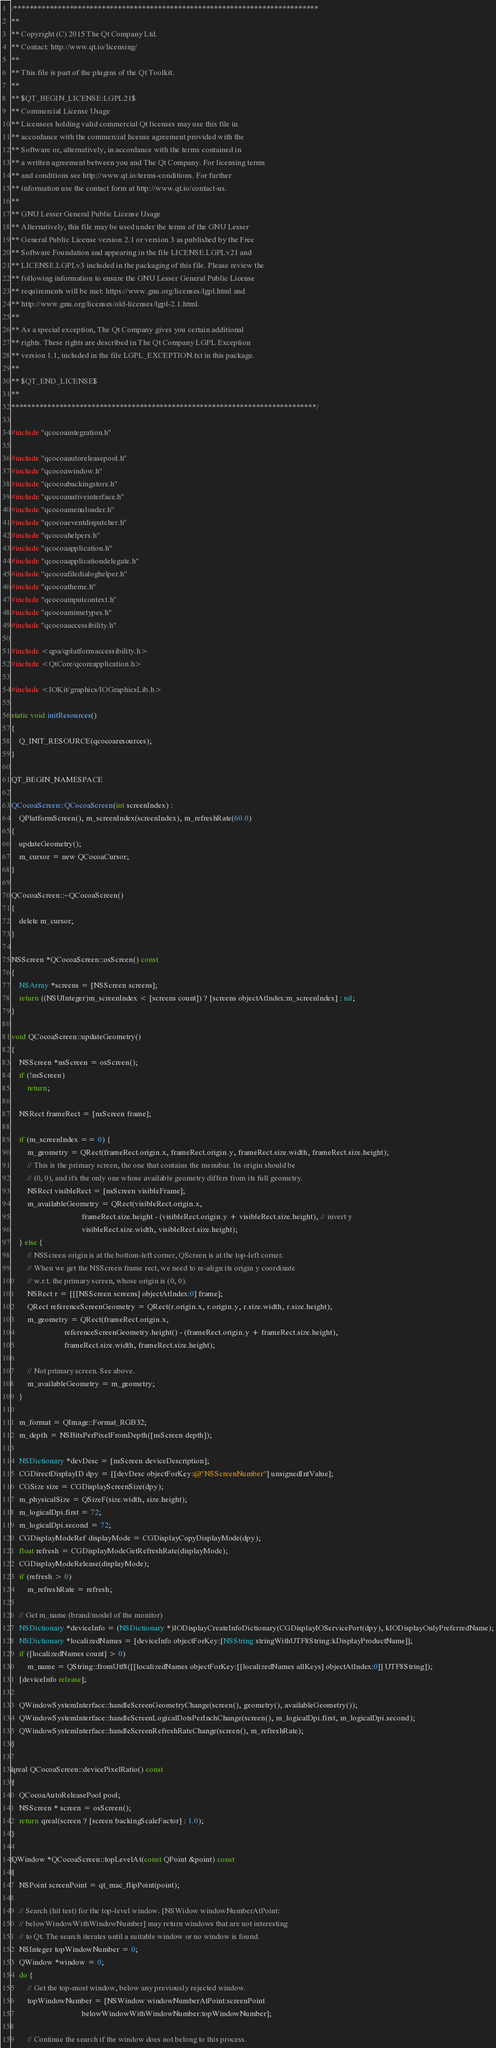<code> <loc_0><loc_0><loc_500><loc_500><_ObjectiveC_>/****************************************************************************
**
** Copyright (C) 2015 The Qt Company Ltd.
** Contact: http://www.qt.io/licensing/
**
** This file is part of the plugins of the Qt Toolkit.
**
** $QT_BEGIN_LICENSE:LGPL21$
** Commercial License Usage
** Licensees holding valid commercial Qt licenses may use this file in
** accordance with the commercial license agreement provided with the
** Software or, alternatively, in accordance with the terms contained in
** a written agreement between you and The Qt Company. For licensing terms
** and conditions see http://www.qt.io/terms-conditions. For further
** information use the contact form at http://www.qt.io/contact-us.
**
** GNU Lesser General Public License Usage
** Alternatively, this file may be used under the terms of the GNU Lesser
** General Public License version 2.1 or version 3 as published by the Free
** Software Foundation and appearing in the file LICENSE.LGPLv21 and
** LICENSE.LGPLv3 included in the packaging of this file. Please review the
** following information to ensure the GNU Lesser General Public License
** requirements will be met: https://www.gnu.org/licenses/lgpl.html and
** http://www.gnu.org/licenses/old-licenses/lgpl-2.1.html.
**
** As a special exception, The Qt Company gives you certain additional
** rights. These rights are described in The Qt Company LGPL Exception
** version 1.1, included in the file LGPL_EXCEPTION.txt in this package.
**
** $QT_END_LICENSE$
**
****************************************************************************/

#include "qcocoaintegration.h"

#include "qcocoaautoreleasepool.h"
#include "qcocoawindow.h"
#include "qcocoabackingstore.h"
#include "qcocoanativeinterface.h"
#include "qcocoamenuloader.h"
#include "qcocoaeventdispatcher.h"
#include "qcocoahelpers.h"
#include "qcocoaapplication.h"
#include "qcocoaapplicationdelegate.h"
#include "qcocoafiledialoghelper.h"
#include "qcocoatheme.h"
#include "qcocoainputcontext.h"
#include "qcocoamimetypes.h"
#include "qcocoaaccessibility.h"

#include <qpa/qplatformaccessibility.h>
#include <QtCore/qcoreapplication.h>

#include <IOKit/graphics/IOGraphicsLib.h>

static void initResources()
{
    Q_INIT_RESOURCE(qcocoaresources);
}

QT_BEGIN_NAMESPACE

QCocoaScreen::QCocoaScreen(int screenIndex) :
    QPlatformScreen(), m_screenIndex(screenIndex), m_refreshRate(60.0)
{
    updateGeometry();
    m_cursor = new QCocoaCursor;
}

QCocoaScreen::~QCocoaScreen()
{
    delete m_cursor;
}

NSScreen *QCocoaScreen::osScreen() const
{
    NSArray *screens = [NSScreen screens];
    return ((NSUInteger)m_screenIndex < [screens count]) ? [screens objectAtIndex:m_screenIndex] : nil;
}

void QCocoaScreen::updateGeometry()
{
    NSScreen *nsScreen = osScreen();
    if (!nsScreen)
        return;

    NSRect frameRect = [nsScreen frame];

    if (m_screenIndex == 0) {
        m_geometry = QRect(frameRect.origin.x, frameRect.origin.y, frameRect.size.width, frameRect.size.height);
        // This is the primary screen, the one that contains the menubar. Its origin should be
        // (0, 0), and it's the only one whose available geometry differs from its full geometry.
        NSRect visibleRect = [nsScreen visibleFrame];
        m_availableGeometry = QRect(visibleRect.origin.x,
                                    frameRect.size.height - (visibleRect.origin.y + visibleRect.size.height), // invert y
                                    visibleRect.size.width, visibleRect.size.height);
    } else {
        // NSScreen origin is at the bottom-left corner, QScreen is at the top-left corner.
        // When we get the NSScreen frame rect, we need to re-align its origin y coordinate
        // w.r.t. the primary screen, whose origin is (0, 0).
        NSRect r = [[[NSScreen screens] objectAtIndex:0] frame];
        QRect referenceScreenGeometry = QRect(r.origin.x, r.origin.y, r.size.width, r.size.height);
        m_geometry = QRect(frameRect.origin.x,
                           referenceScreenGeometry.height() - (frameRect.origin.y + frameRect.size.height),
                           frameRect.size.width, frameRect.size.height);

        // Not primary screen. See above.
        m_availableGeometry = m_geometry;
    }

    m_format = QImage::Format_RGB32;
    m_depth = NSBitsPerPixelFromDepth([nsScreen depth]);

    NSDictionary *devDesc = [nsScreen deviceDescription];
    CGDirectDisplayID dpy = [[devDesc objectForKey:@"NSScreenNumber"] unsignedIntValue];
    CGSize size = CGDisplayScreenSize(dpy);
    m_physicalSize = QSizeF(size.width, size.height);
    m_logicalDpi.first = 72;
    m_logicalDpi.second = 72;
    CGDisplayModeRef displayMode = CGDisplayCopyDisplayMode(dpy);
    float refresh = CGDisplayModeGetRefreshRate(displayMode);
    CGDisplayModeRelease(displayMode);
    if (refresh > 0)
        m_refreshRate = refresh;

    // Get m_name (brand/model of the monitor)
    NSDictionary *deviceInfo = (NSDictionary *)IODisplayCreateInfoDictionary(CGDisplayIOServicePort(dpy), kIODisplayOnlyPreferredName);
    NSDictionary *localizedNames = [deviceInfo objectForKey:[NSString stringWithUTF8String:kDisplayProductName]];
    if ([localizedNames count] > 0)
        m_name = QString::fromUtf8([[localizedNames objectForKey:[[localizedNames allKeys] objectAtIndex:0]] UTF8String]);
    [deviceInfo release];

    QWindowSystemInterface::handleScreenGeometryChange(screen(), geometry(), availableGeometry());
    QWindowSystemInterface::handleScreenLogicalDotsPerInchChange(screen(), m_logicalDpi.first, m_logicalDpi.second);
    QWindowSystemInterface::handleScreenRefreshRateChange(screen(), m_refreshRate);
}

qreal QCocoaScreen::devicePixelRatio() const
{
    QCocoaAutoReleasePool pool;
    NSScreen * screen = osScreen();
    return qreal(screen ? [screen backingScaleFactor] : 1.0);
}

QWindow *QCocoaScreen::topLevelAt(const QPoint &point) const
{
    NSPoint screenPoint = qt_mac_flipPoint(point);

    // Search (hit test) for the top-level window. [NSWidow windowNumberAtPoint:
    // belowWindowWithWindowNumber] may return windows that are not interesting
    // to Qt. The search iterates until a suitable window or no window is found.
    NSInteger topWindowNumber = 0;
    QWindow *window = 0;
    do {
        // Get the top-most window, below any previously rejected window.
        topWindowNumber = [NSWindow windowNumberAtPoint:screenPoint
                                    belowWindowWithWindowNumber:topWindowNumber];

        // Continue the search if the window does not belong to this process.</code> 